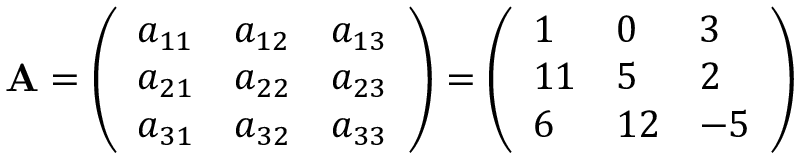Convert formula to latex. <formula><loc_0><loc_0><loc_500><loc_500>A = { \left ( \begin{array} { l l l } { a _ { 1 1 } } & { a _ { 1 2 } } & { a _ { 1 3 } } \\ { a _ { 2 1 } } & { a _ { 2 2 } } & { a _ { 2 3 } } \\ { a _ { 3 1 } } & { a _ { 3 2 } } & { a _ { 3 3 } } \end{array} \right ) } = { \left ( \begin{array} { l l l } { 1 } & { 0 } & { 3 } \\ { 1 1 } & { 5 } & { 2 } \\ { 6 } & { 1 2 } & { - 5 } \end{array} \right ) }</formula> 